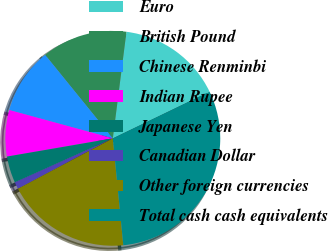<chart> <loc_0><loc_0><loc_500><loc_500><pie_chart><fcel>Euro<fcel>British Pound<fcel>Chinese Renminbi<fcel>Indian Rupee<fcel>Japanese Yen<fcel>Canadian Dollar<fcel>Other foreign currencies<fcel>Total cash cash equivalents<nl><fcel>15.82%<fcel>12.87%<fcel>9.91%<fcel>6.96%<fcel>4.01%<fcel>1.05%<fcel>18.78%<fcel>30.6%<nl></chart> 